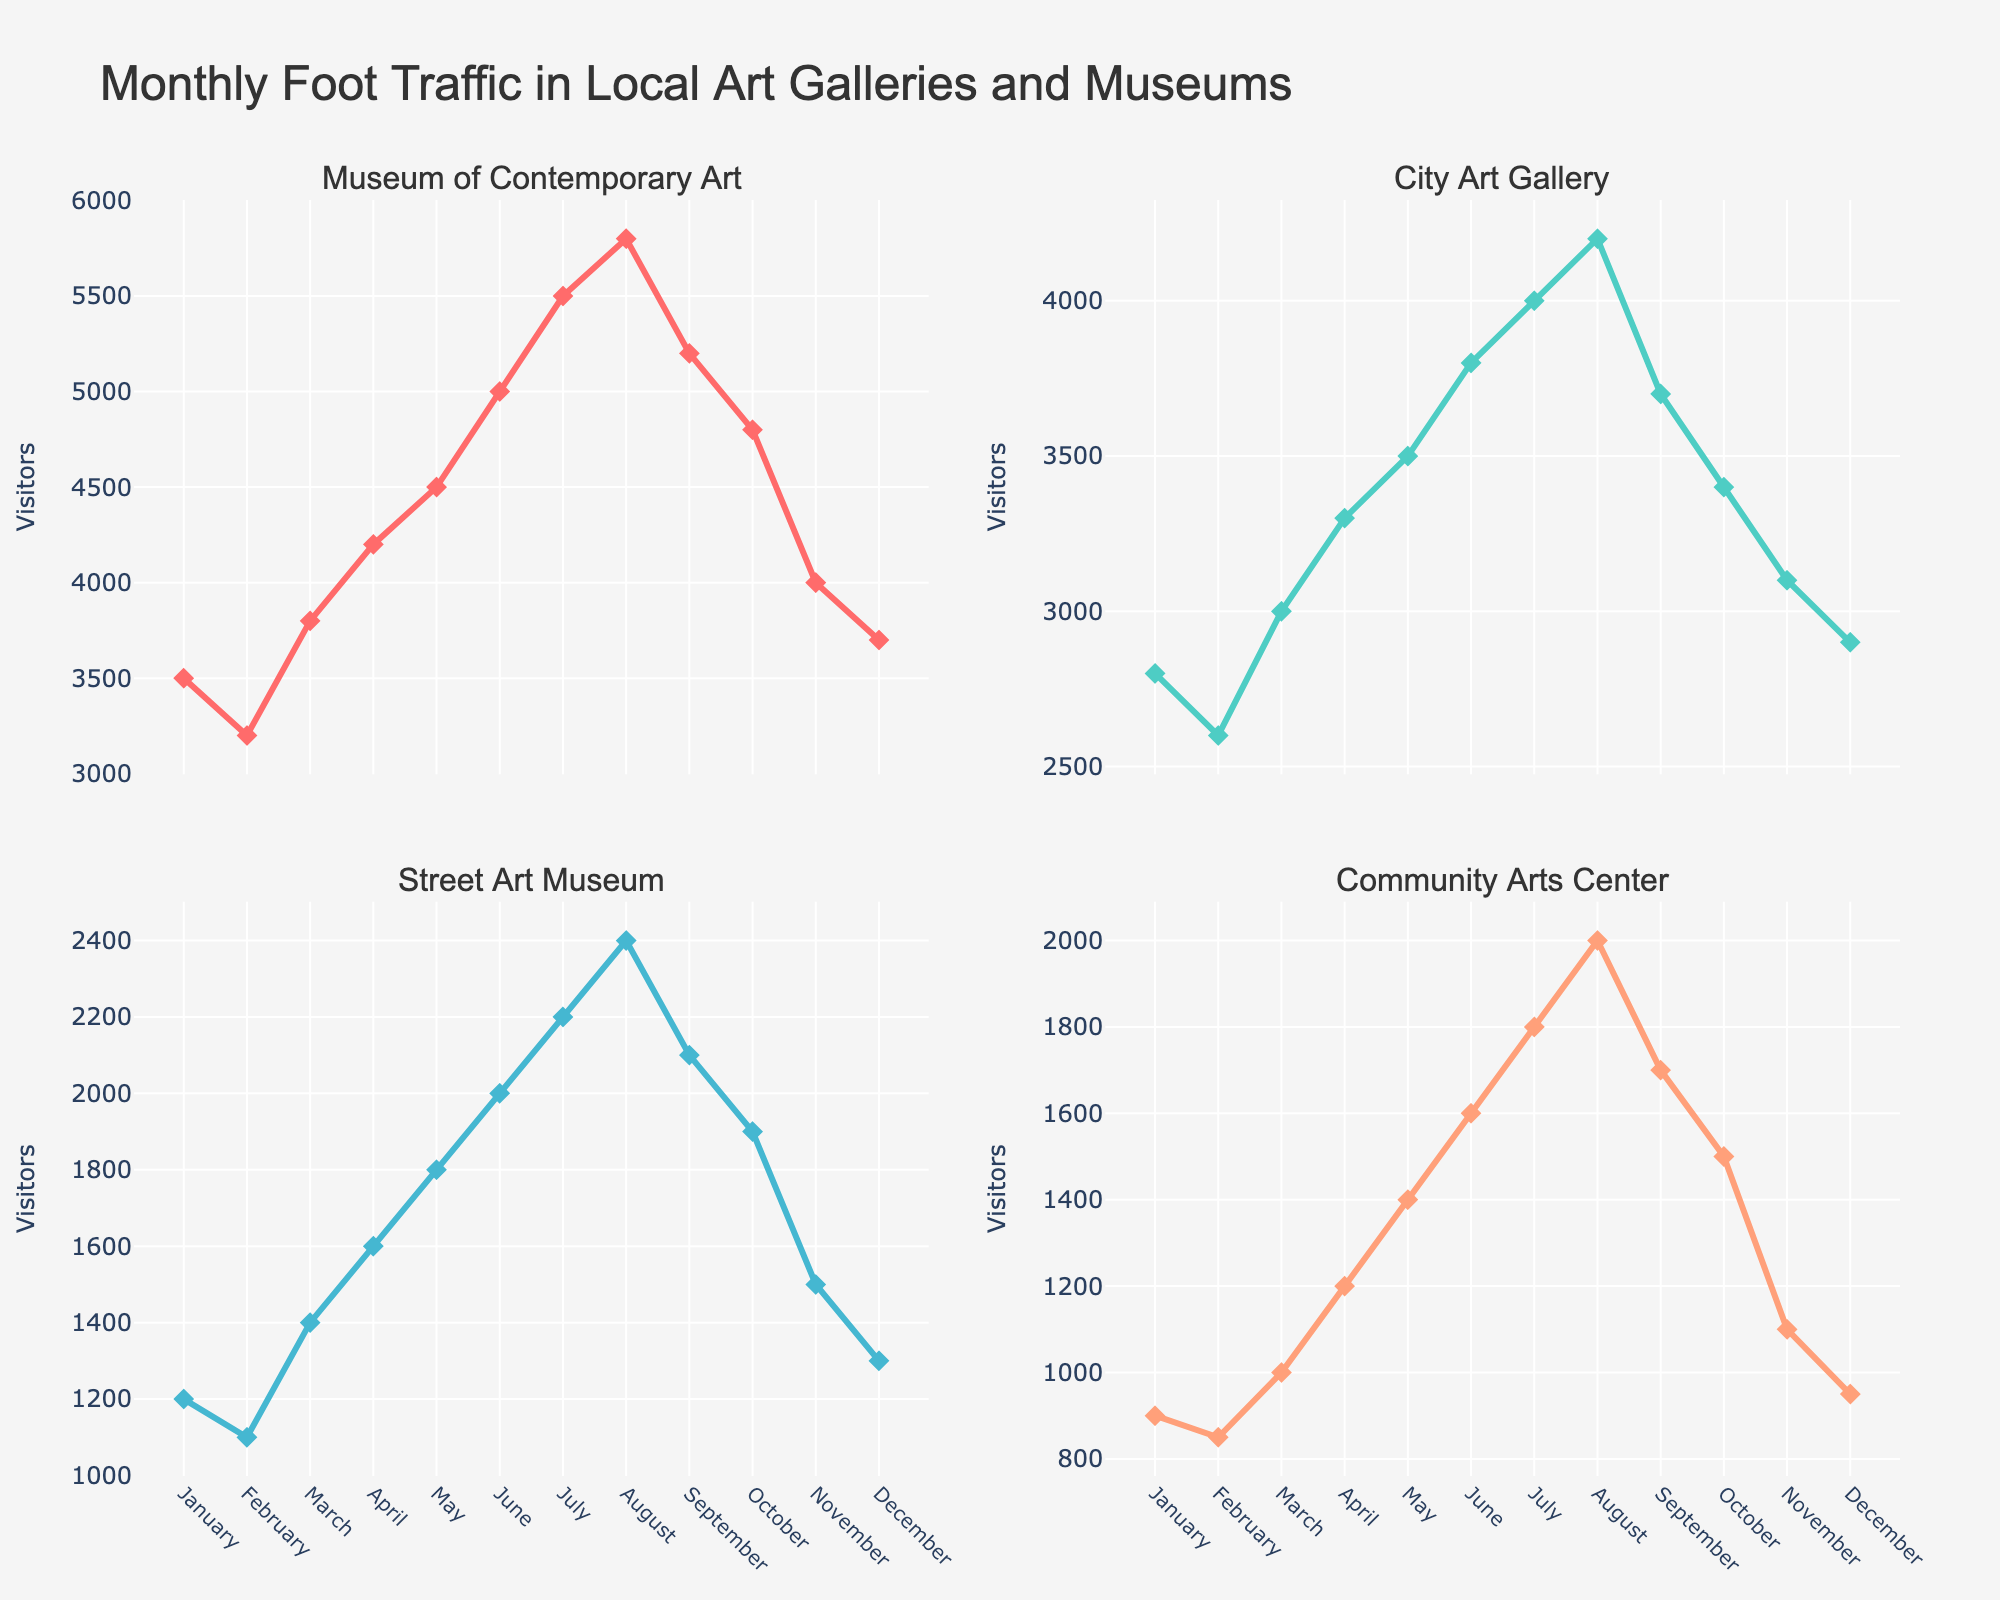What is the title of the plot? The plot title is usually displayed prominently at the top of the figure. In this case, it reads "Monthly Foot Traffic in Local Art Galleries and Museums".
Answer: Monthly Foot Traffic in Local Art Galleries and Museums How many subplots are in the figure? The figure is divided into smaller plots called subplots. Here, we can see there are four subplots, one for each art gallery or museum.
Answer: 4 Which month had the highest foot traffic for the Museum of Contemporary Art? By looking at the line representing the Museum of Contemporary Art on its corresponding subplot, the peak is during August.
Answer: August In which month did the Community Arts Center see twice as many visitors as it did in January? Comparing the data points on the Community Arts Center subplot, January has 900 visitors, and June has 1600 visitors, which is more than double.
Answer: June On average, how many visitors did the Street Art Museum receive per month? Sum all the monthly visitors for the Street Art Museum (1200 + 1100 + 1400 + 1600 + 1800 + 2000 + 2200 + 2400 + 2100 + 1900 + 1500 + 1300) = 21500, then divide by 12 (number of months), resulting in an average of 1791.67.
Answer: 1791.67 Between which two months did the City Art Gallery's foot traffic increase the most? The largest increase for the City Art Gallery can be observed from the corresponding subplot, and that increase is from June (3800) to July (4000), an increase of 200 visitors.
Answer: June to July Which institution had the least foot traffic in December, and what was the number? By comparing the December data points across all subplots, the Community Arts Center had the least with 950 visitors.
Answer: Community Arts Center, 950 What is the common trend of foot traffic in all the institutions from January to July? Observing all subplots from January to July shows a general increasing trend in foot traffic across all institutions.
Answer: Increasing Which month shows the greatest difference in visitor numbers between the Museum of Contemporary Art and the Community Arts Center? The greatest difference is found by computing the differences month by month. In August, the difference is the largest: 5800 (Museum of Contemporary Art) - 2000 (Community Arts Center) = 3800.
Answer: August, 3800 What is the overall trend in foot traffic for the City Art Gallery from August to December? The line for the City Art Gallery subplot from August to December shows a decreasing trend.
Answer: Decreasing 